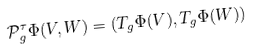<formula> <loc_0><loc_0><loc_500><loc_500>\mathcal { P } ^ { \tau } _ { g } \Phi ( V , W ) = ( T _ { g } \Phi ( V ) , T _ { g } \Phi ( W ) )</formula> 